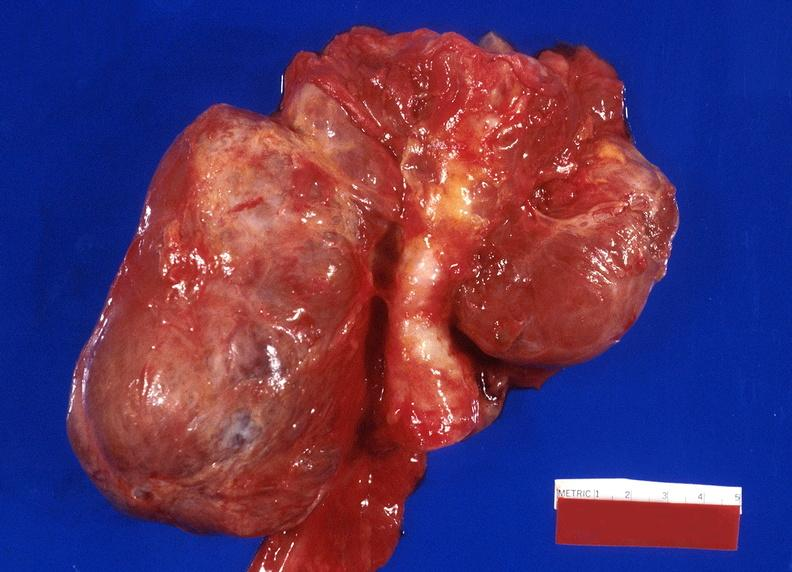does this image show thyroid, goiter?
Answer the question using a single word or phrase. Yes 